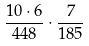Convert formula to latex. <formula><loc_0><loc_0><loc_500><loc_500>\frac { 1 0 \cdot 6 } { 4 4 8 } \cdot \frac { 7 } { 1 8 5 }</formula> 